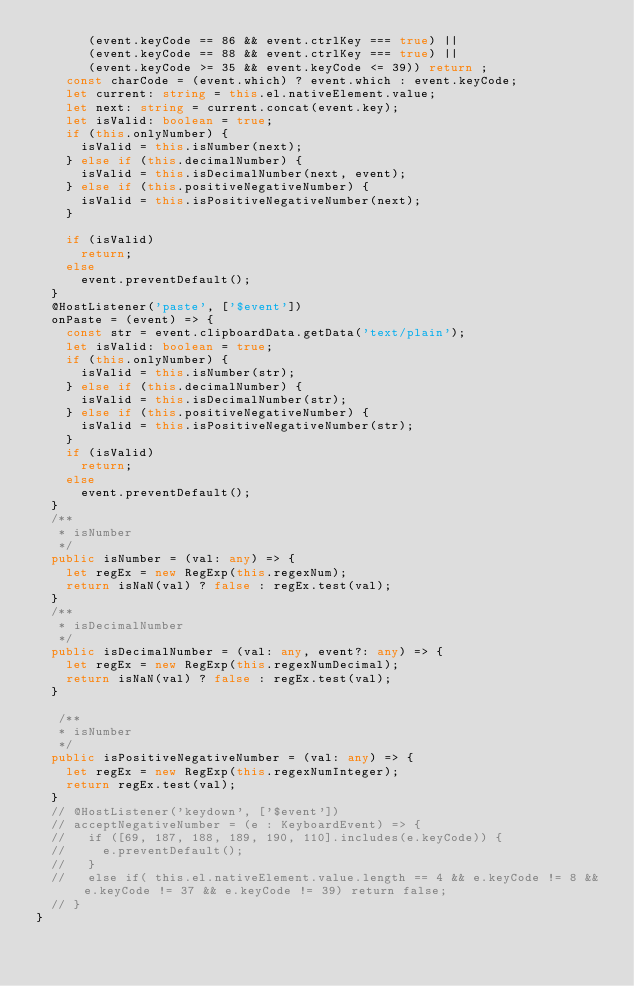<code> <loc_0><loc_0><loc_500><loc_500><_TypeScript_>       (event.keyCode == 86 && event.ctrlKey === true) || 
       (event.keyCode == 88 && event.ctrlKey === true) || 
       (event.keyCode >= 35 && event.keyCode <= 39)) return ;
    const charCode = (event.which) ? event.which : event.keyCode;
    let current: string = this.el.nativeElement.value;
    let next: string = current.concat(event.key);
    let isValid: boolean = true;
    if (this.onlyNumber) {
      isValid = this.isNumber(next);
    } else if (this.decimalNumber) {
      isValid = this.isDecimalNumber(next, event);
    } else if (this.positiveNegativeNumber) {      
      isValid = this.isPositiveNegativeNumber(next);
    }

    if (isValid)
      return;
    else
      event.preventDefault();
  }
  @HostListener('paste', ['$event'])
  onPaste = (event) => {
    const str = event.clipboardData.getData('text/plain');
    let isValid: boolean = true;
    if (this.onlyNumber) {
      isValid = this.isNumber(str);
    } else if (this.decimalNumber) {
      isValid = this.isDecimalNumber(str);
    } else if (this.positiveNegativeNumber) {
      isValid = this.isPositiveNegativeNumber(str);
    }
    if (isValid)
      return;
    else
      event.preventDefault();
  }
  /**
   * isNumber
   */
  public isNumber = (val: any) => {
    let regEx = new RegExp(this.regexNum);
    return isNaN(val) ? false : regEx.test(val);
  }
  /**
   * isDecimalNumber
   */
  public isDecimalNumber = (val: any, event?: any) => {
    let regEx = new RegExp(this.regexNumDecimal);
    return isNaN(val) ? false : regEx.test(val);
  }

   /**
   * isNumber
   */
  public isPositiveNegativeNumber = (val: any) => {
    let regEx = new RegExp(this.regexNumInteger);
    return regEx.test(val);
  }
  // @HostListener('keydown', ['$event'])
  // acceptNegativeNumber = (e : KeyboardEvent) => { 
  //   if ([69, 187, 188, 189, 190, 110].includes(e.keyCode)) {
  //     e.preventDefault();
  //   }
  //   else if( this.el.nativeElement.value.length == 4 && e.keyCode != 8 && e.keyCode != 37 && e.keyCode != 39) return false;
  // }
}
</code> 